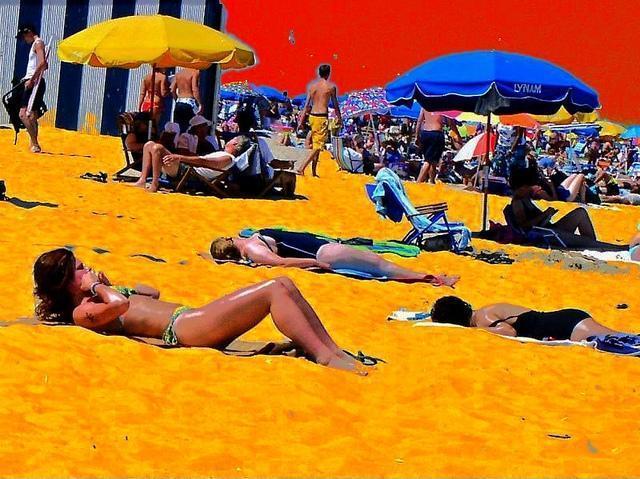How many people are visible?
Give a very brief answer. 7. How many umbrellas can you see?
Give a very brief answer. 2. How many buses are solid blue?
Give a very brief answer. 0. 